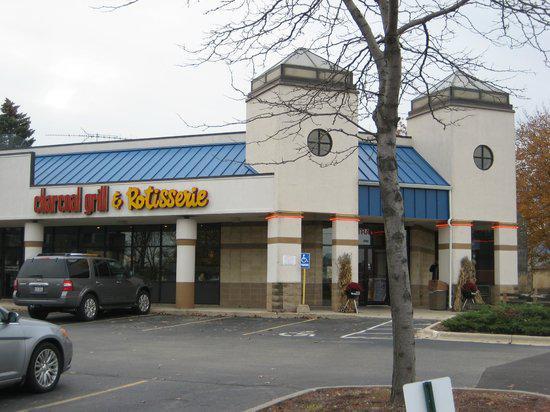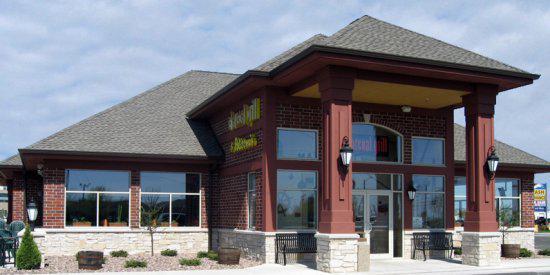The first image is the image on the left, the second image is the image on the right. Evaluate the accuracy of this statement regarding the images: "In one image, an outdoor seating area in front of a building includes at least two solid-colored patio umbrellas.". Is it true? Answer yes or no. No. The first image is the image on the left, the second image is the image on the right. For the images displayed, is the sentence "There are at most 2 umbrellas in the image on the right." factually correct? Answer yes or no. No. 